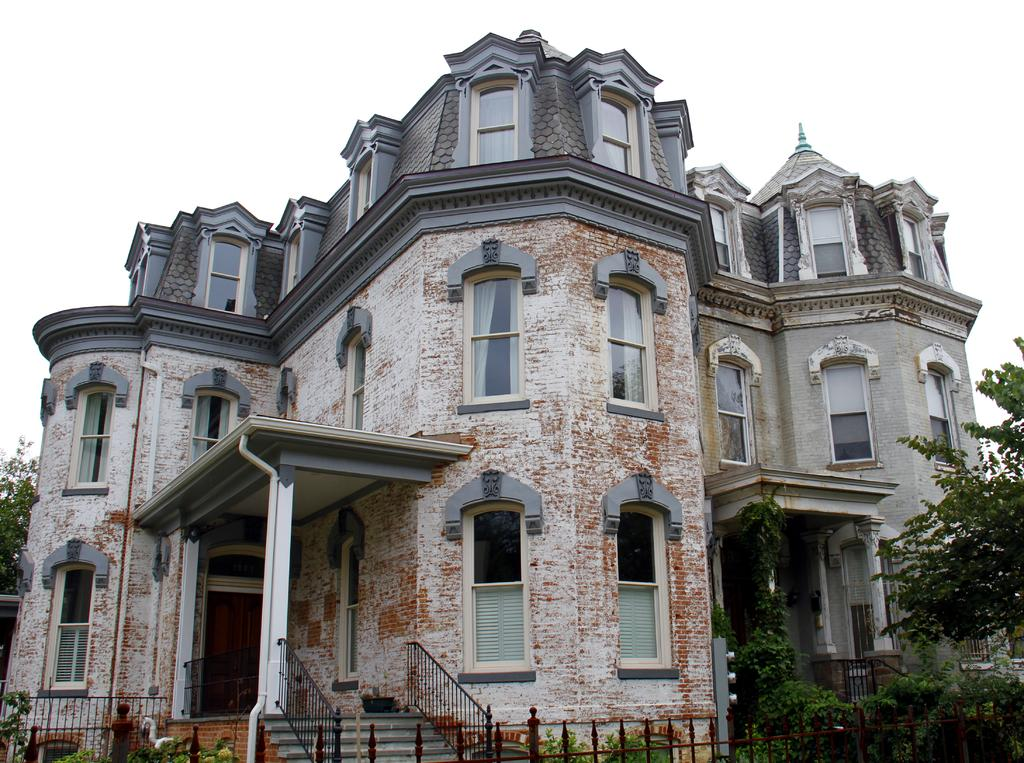What type of structure is in the image? There is a building in the image. What features can be seen on the building? The building has windows and pillars. What architectural elements are present in the image? There are steps and a fence in the image. What natural elements can be seen in the image? There are trees in the image. What is visible in the background of the image? The sky is visible in the background of the image. Can you see a goose playing with a ball on the island in the image? There is no goose, ball, or island present in the image. 